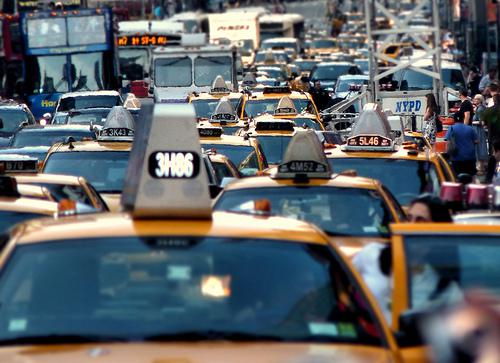Question: what are the yellow cars?
Choices:
A. Taxis.
B. Buses.
C. Ambulances.
D. Police cars.
Answer with the letter. Answer: A Question: where was this taken?
Choices:
A. Mountain slope.
B. Beach.
C. Horse trail.
D. City street.
Answer with the letter. Answer: D Question: when was this taken?
Choices:
A. Day time.
B. Midnight.
C. At dawn.
D. At sunset.
Answer with the letter. Answer: A Question: who is getting in a taxi?
Choices:
A. Old man.
B. Two women.
C. Young lady.
D. Young man.
Answer with the letter. Answer: C Question: what color are the taxis?
Choices:
A. Yellow.
B. Red.
C. White.
D. Black.
Answer with the letter. Answer: A Question: where was this taken?
Choices:
A. Las Vegas.
B. San Diego.
C. London.
D. New York City.
Answer with the letter. Answer: D Question: what taxi is numbered 3H86?
Choices:
A. The one on the left.
B. Closest one.
C. The one on the right.
D. The one in back.
Answer with the letter. Answer: B 